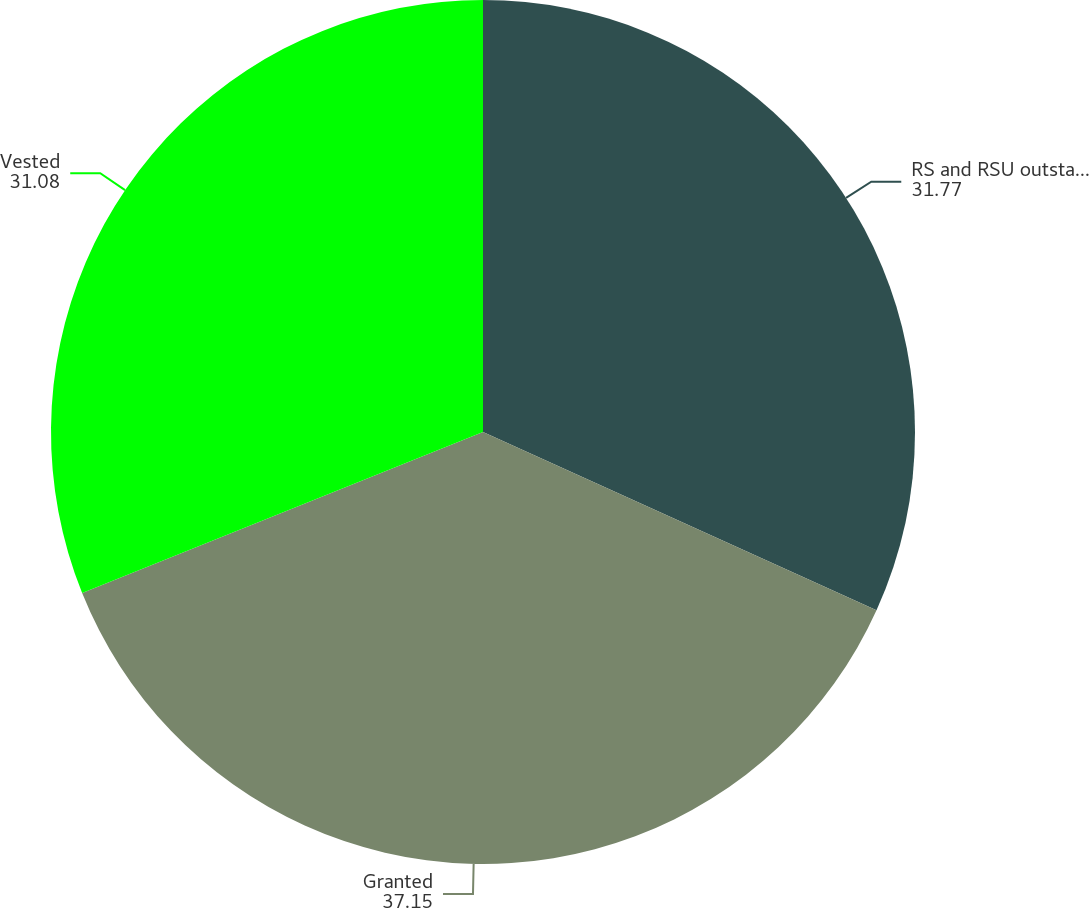Convert chart. <chart><loc_0><loc_0><loc_500><loc_500><pie_chart><fcel>RS and RSU outstanding at<fcel>Granted<fcel>Vested<nl><fcel>31.77%<fcel>37.15%<fcel>31.08%<nl></chart> 